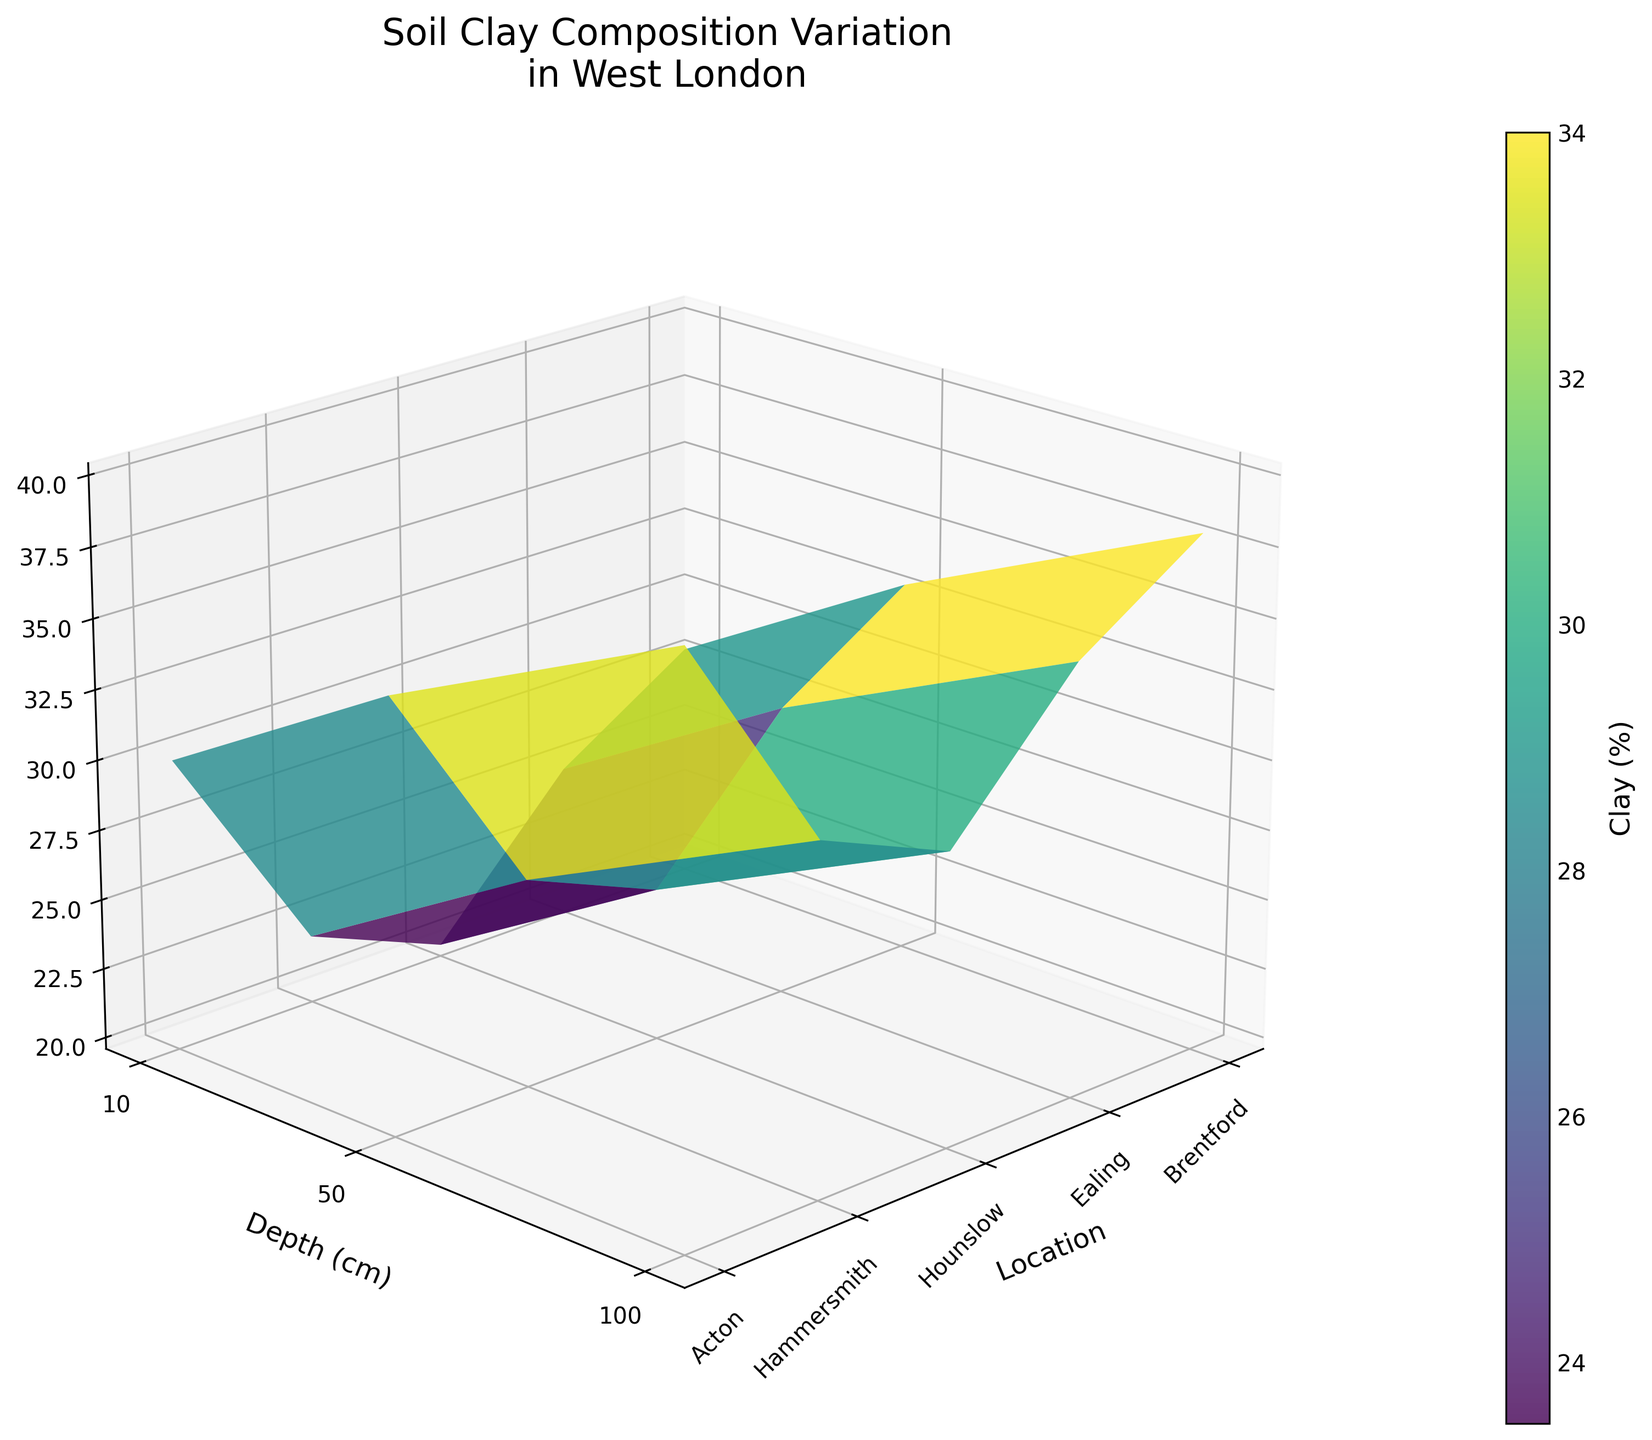What's the title of the plot? The title is usually located at the top of the plot and it summarizes what the graph is about.
Answer: Soil Clay Composition Variation in West London Which location appears to have the highest clay percentage at a depth of 10 cm? By looking at the surface plot, find the 10 cm depth line and check which location peak reaches the highest clay percentage value.
Answer: Hounslow How does the clay percentage in Ealing at 50 cm depth compare to that in Acton at the same depth? Locate the 50 cm depth line for Ealing and Acton, and compare the heights of the surface at these locations.
Answer: Ealing has less clay percentage than Acton What is the average clay percentage at 100 cm depth across all locations? Sum up the clay percentages at 100 cm depth for all locations and divide by the number of locations. (35 + 30 + 40 + 32 + 38)/5 = 35
Answer: 35% Do all locations have clay percentage above 30% at 100 cm depth? Check the clay percentage values for 100 cm depth for all locations to see if each value is greater than 30%. Values are 35, 30, 40, 32, 38 which all are greater than 30
Answer: Yes Which location has the most gradual change in clay percentage over depth (10 cm to 100 cm)? Calculate the changes in clay percentage values between each depth increment for all locations and choose the location with the least overall change. Difference Calculation:- Brentford: 25 to 35 (Change by 10)- Ealing: 20 to 30 (Change by 10)- Hounslow: 30 to 40 (Change by 10)- Hammersmith: 22 to 32 (Change by 10)- Acton: 28 to 38 (Change by 10)- As all changes are gradual and equal, the answer could be "all locations" again
Answer: All locations At which depths do all locations show clay percentage values above 20%? Verify if all the clay percentage values at each depth (10 cm, 50 cm, and 100 cm) are greater than 20%. Values are:- 10 cm: 25, 20, 30, 22, 28 (all > 20)- 50 cm: 30, 25, 35, 27, 33 (all > 20)- 100 cm: 35, 30, 40, 32, 38 (all > 20)- All depths are > 20
Answer: 10 cm, 50 cm, 100 cm 